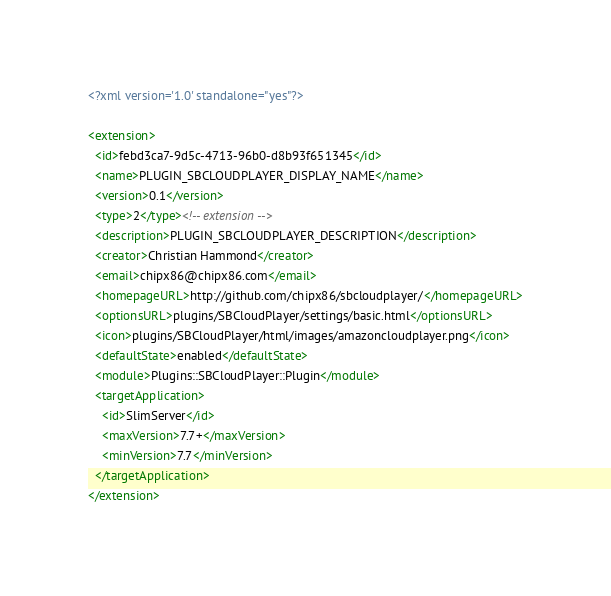<code> <loc_0><loc_0><loc_500><loc_500><_XML_><?xml version='1.0' standalone="yes"?>

<extension>
  <id>febd3ca7-9d5c-4713-96b0-d8b93f651345</id>
  <name>PLUGIN_SBCLOUDPLAYER_DISPLAY_NAME</name>
  <version>0.1</version>
  <type>2</type><!-- extension -->
  <description>PLUGIN_SBCLOUDPLAYER_DESCRIPTION</description>
  <creator>Christian Hammond</creator>
  <email>chipx86@chipx86.com</email>
  <homepageURL>http://github.com/chipx86/sbcloudplayer/</homepageURL>
  <optionsURL>plugins/SBCloudPlayer/settings/basic.html</optionsURL>
  <icon>plugins/SBCloudPlayer/html/images/amazoncloudplayer.png</icon>
  <defaultState>enabled</defaultState>
  <module>Plugins::SBCloudPlayer::Plugin</module>
  <targetApplication>
    <id>SlimServer</id>
    <maxVersion>7.7+</maxVersion>
    <minVersion>7.7</minVersion>
  </targetApplication>
</extension>
</code> 